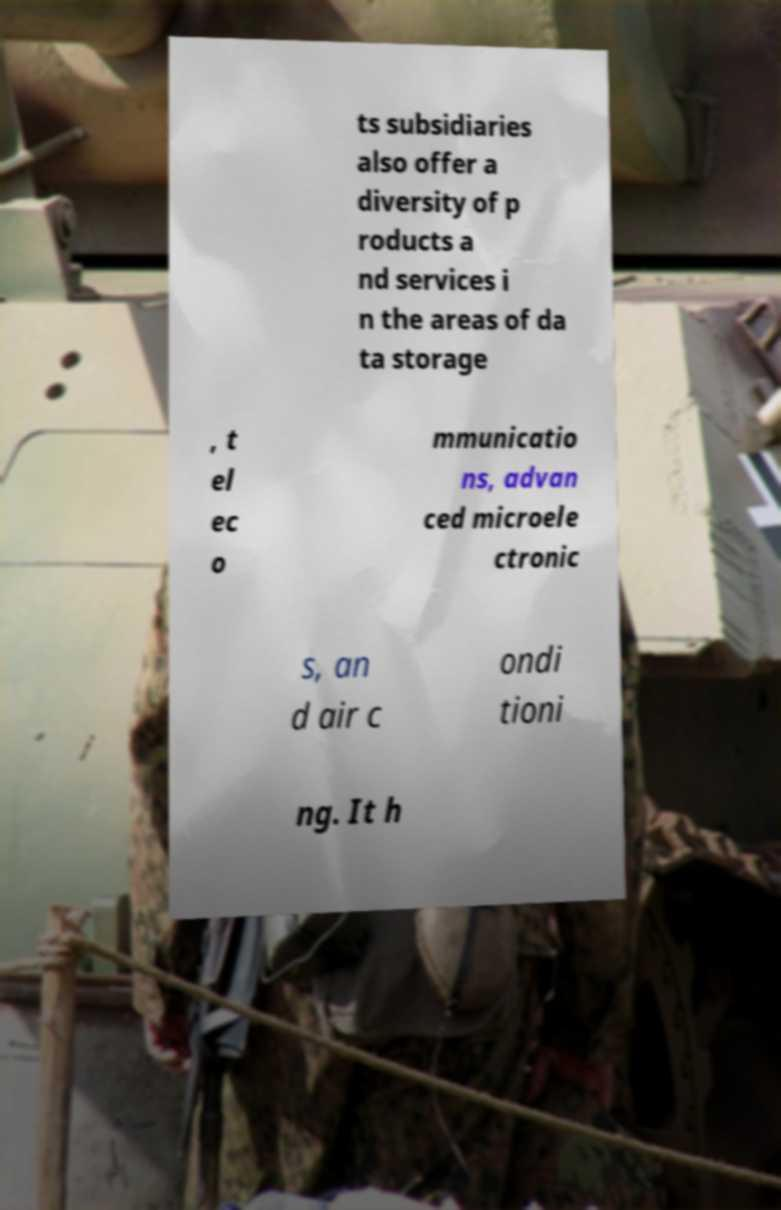Please identify and transcribe the text found in this image. ts subsidiaries also offer a diversity of p roducts a nd services i n the areas of da ta storage , t el ec o mmunicatio ns, advan ced microele ctronic s, an d air c ondi tioni ng. It h 